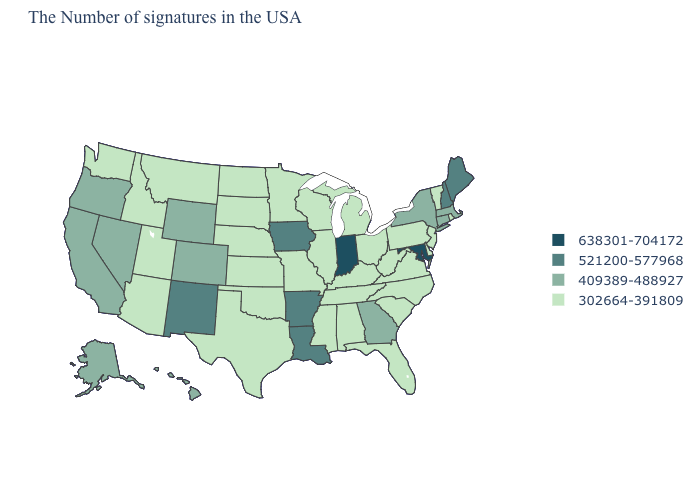Which states have the lowest value in the Northeast?
Short answer required. Rhode Island, Vermont, New Jersey, Pennsylvania. Does Utah have the lowest value in the West?
Answer briefly. Yes. Name the states that have a value in the range 638301-704172?
Write a very short answer. Maryland, Indiana. Which states have the lowest value in the USA?
Keep it brief. Rhode Island, Vermont, New Jersey, Delaware, Pennsylvania, Virginia, North Carolina, South Carolina, West Virginia, Ohio, Florida, Michigan, Kentucky, Alabama, Tennessee, Wisconsin, Illinois, Mississippi, Missouri, Minnesota, Kansas, Nebraska, Oklahoma, Texas, South Dakota, North Dakota, Utah, Montana, Arizona, Idaho, Washington. Which states hav the highest value in the MidWest?
Quick response, please. Indiana. Name the states that have a value in the range 521200-577968?
Give a very brief answer. Maine, New Hampshire, Louisiana, Arkansas, Iowa, New Mexico. Does Alaska have the highest value in the USA?
Short answer required. No. Among the states that border New York , which have the highest value?
Answer briefly. Massachusetts, Connecticut. Name the states that have a value in the range 409389-488927?
Be succinct. Massachusetts, Connecticut, New York, Georgia, Wyoming, Colorado, Nevada, California, Oregon, Alaska, Hawaii. What is the value of Massachusetts?
Concise answer only. 409389-488927. Does Michigan have the lowest value in the MidWest?
Write a very short answer. Yes. Name the states that have a value in the range 521200-577968?
Quick response, please. Maine, New Hampshire, Louisiana, Arkansas, Iowa, New Mexico. Does Georgia have the lowest value in the South?
Keep it brief. No. What is the value of Minnesota?
Concise answer only. 302664-391809. Which states have the lowest value in the Northeast?
Quick response, please. Rhode Island, Vermont, New Jersey, Pennsylvania. 